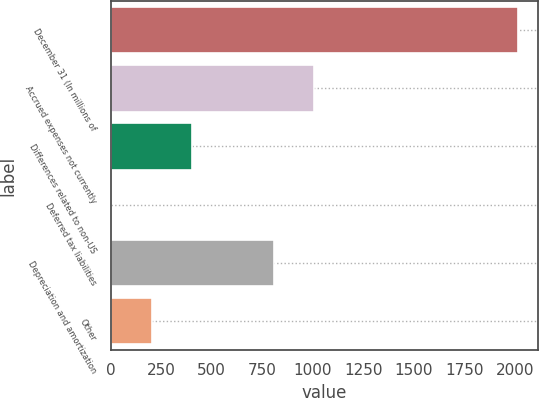Convert chart to OTSL. <chart><loc_0><loc_0><loc_500><loc_500><bar_chart><fcel>December 31 (In millions of<fcel>Accrued expenses not currently<fcel>Differences related to non-US<fcel>Deferred tax liabilities<fcel>Depreciation and amortization<fcel>Other<nl><fcel>2013<fcel>1007.5<fcel>404.2<fcel>2<fcel>806.4<fcel>203.1<nl></chart> 